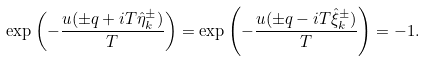<formula> <loc_0><loc_0><loc_500><loc_500>\exp \left ( - \frac { u ( \pm q + i T \hat { \eta } ^ { \pm } _ { k } ) } T \right ) = \exp \left ( - \frac { u ( \pm q - i T \hat { \xi } ^ { \pm } _ { k } ) } T \right ) = - 1 .</formula> 